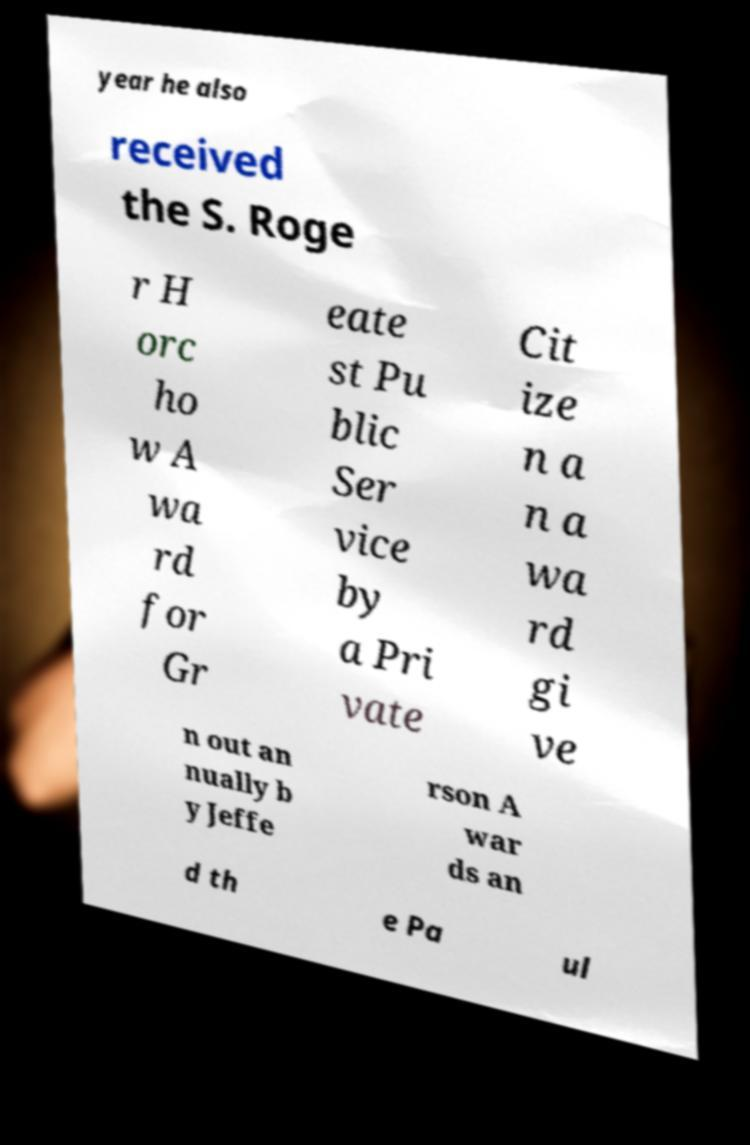For documentation purposes, I need the text within this image transcribed. Could you provide that? year he also received the S. Roge r H orc ho w A wa rd for Gr eate st Pu blic Ser vice by a Pri vate Cit ize n a n a wa rd gi ve n out an nually b y Jeffe rson A war ds an d th e Pa ul 